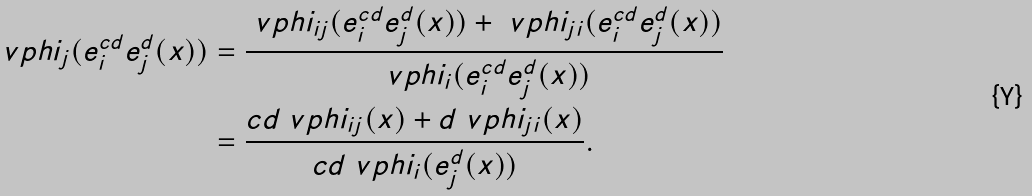Convert formula to latex. <formula><loc_0><loc_0><loc_500><loc_500>\ v p h i _ { j } ( e ^ { c d } _ { i } e ^ { d } _ { j } ( x ) ) & = \frac { \ v p h i _ { i j } ( e ^ { c d } _ { i } e ^ { d } _ { j } ( x ) ) + \ v p h i _ { j i } ( e ^ { c d } _ { i } e ^ { d } _ { j } ( x ) ) } { \ v p h i _ { i } ( e ^ { c d } _ { i } e ^ { d } _ { j } ( x ) ) } \\ & = \frac { c d \ v p h i _ { i j } ( x ) + d \ v p h i _ { j i } ( x ) } { c d \ v p h i _ { i } ( e ^ { d } _ { j } ( x ) ) } .</formula> 